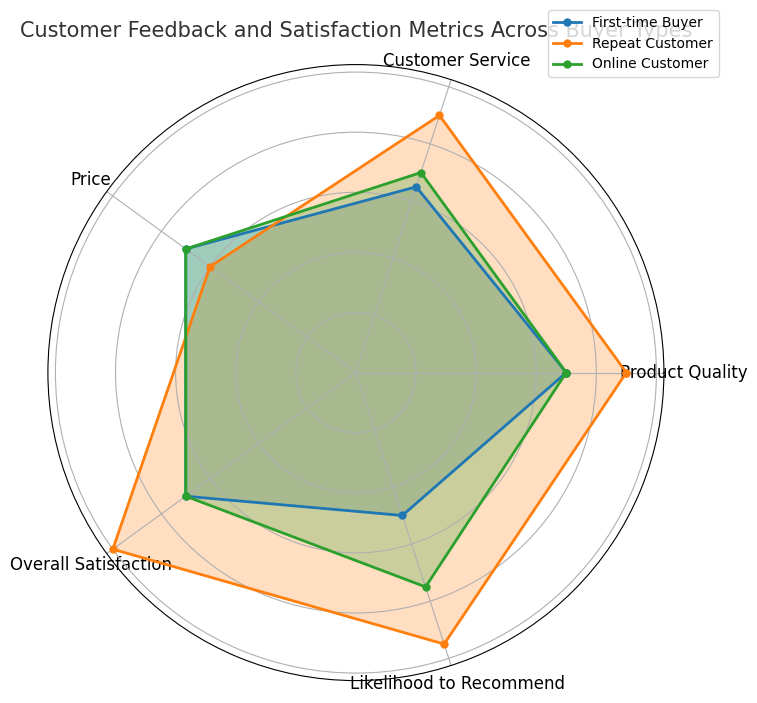What is the average overall satisfaction score for repeat customers? Check the radar chart for the "Repeat Customer" section, add all the values for "Overall Satisfaction", and divide by the number of data points.
Answer: 5 Which buyer type has the highest likelihood to recommend? Compare the "Likelihood to Recommend" category across all buyer types by looking at the length of their lines towards this axis. The longest one corresponds to repeat customers.
Answer: Repeat Customer What is the difference in product quality ratings between first-time buyers and repeat customers? Locate the "Product Quality" axis, note the average ratings for "First-time Buyer" and "Repeat Customer", and subtract the former from the latter.
Answer: 1.0 Among online customers, which category has the highest rating? Observe the categories for online customers and identify the one with the longest line.
Answer: Product Quality, Customer Service, Price, Overall Satisfaction (all are equal) Between first-time buyers and online customers, which group shows a higher average customer service rating? Check the radar chart for the "Customer Service" section, compare the lengths of the lines for "First-time Buyer" and "Online Customer".
Answer: Online Customer What is the sum of the product quality and price ratings for repeat customers? For repeat customers, locate the "Product Quality" and "Price" axes, add the ratings on these axes.
Answer: 8 Which buyer type shows the most evenly distributed ratings across all categories? Look for the buyer type whose lines towards each axis are most uniform in length.
Answer: Online Customer How many buyer types have higher than average ratings in product quality? Identify and count the number of buyer types whose "Product Quality" ratings are above the midpoint on this axis.
Answer: 2 (Repeat Customer, Online Customer) What is the visual difference between customer service ratings for first-time buyers and repeat customers? Compare the heights of the lines corresponding to "Customer Service" for "First-time Buyer" and "Repeat Customer".
Answer: Repeat Customer is higher 